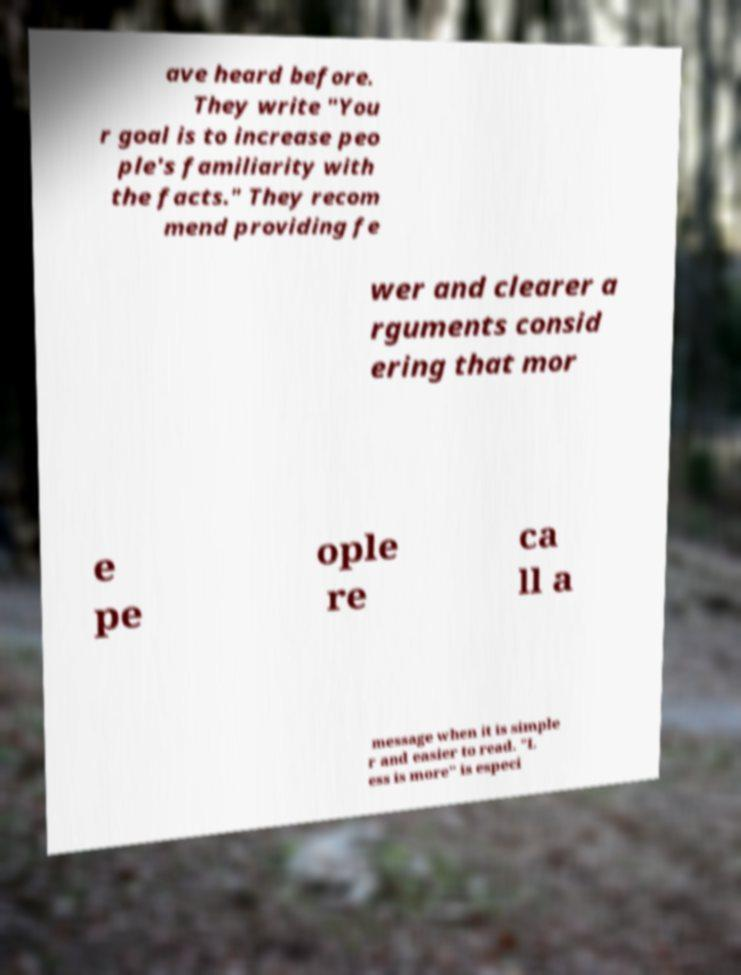I need the written content from this picture converted into text. Can you do that? ave heard before. They write "You r goal is to increase peo ple's familiarity with the facts." They recom mend providing fe wer and clearer a rguments consid ering that mor e pe ople re ca ll a message when it is simple r and easier to read. "L ess is more" is especi 